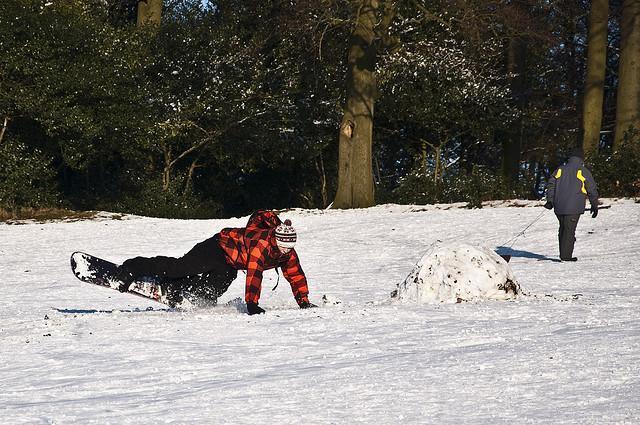How many mounds of snow are there?
Give a very brief answer. 1. How many people are there?
Give a very brief answer. 2. 